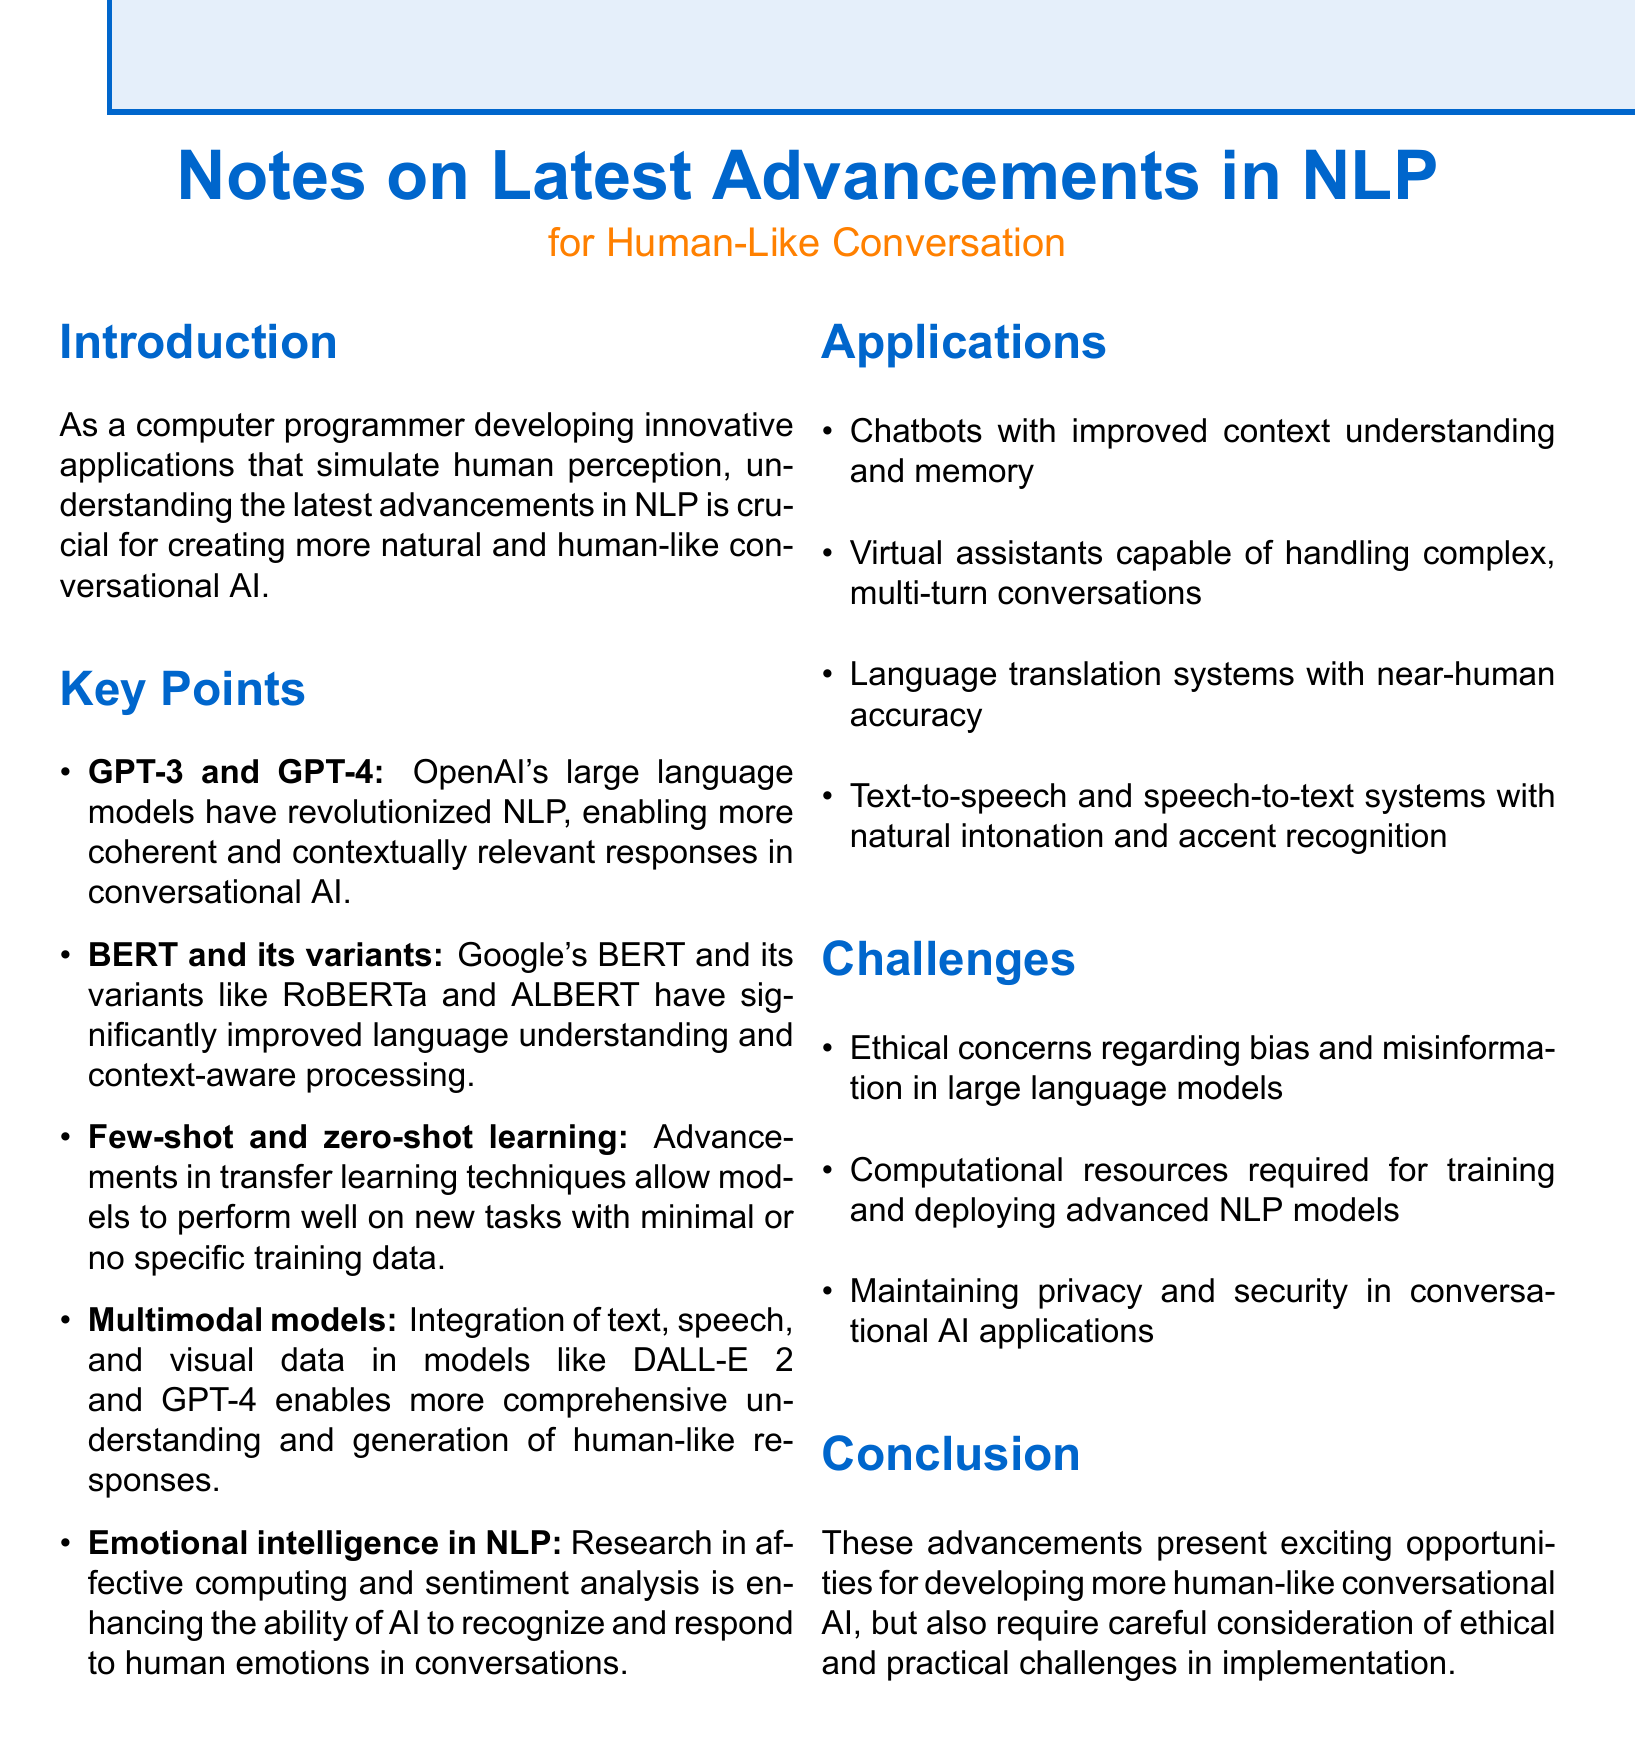What are the names of the large language models mentioned? The large language models mentioned in the document are GPT-3 and GPT-4.
Answer: GPT-3 and GPT-4 What does BERT stand for? The document states that BERT stands for Bidirectional Encoder Representations from Transformers.
Answer: Bidirectional Encoder Representations from Transformers What type of models enable comprehensive understanding in conversational AI? The document describes multimodal models as those that integrate text, speech, and visual data.
Answer: Multimodal models What is a major ethical concern in NLP? Ethical concerns regarding bias and misinformation are highlighted as significant issues.
Answer: Bias and misinformation What is one application of advancements in NLP? The document lists chatbots with improved context understanding and memory as an application.
Answer: Chatbots with improved context understanding and memory Which learning techniques allow models to perform with minimal training data? The document refers to few-shot and zero-shot learning techniques that facilitate this.
Answer: Few-shot and zero-shot learning What is one aspect of emotional intelligence in NLP? The document mentions enhancing AI's ability to recognize and respond to human emotions as a key aspect.
Answer: Recognize and respond to human emotions What is the aim of the advancements discussed? The advancements aim to develop more human-like conversational AI.
Answer: Develop more human-like conversational AI What is necessary for maintaining privacy in conversational AI applications? The document emphasizes the need to address privacy and security as essential concerns.
Answer: Privacy and security 